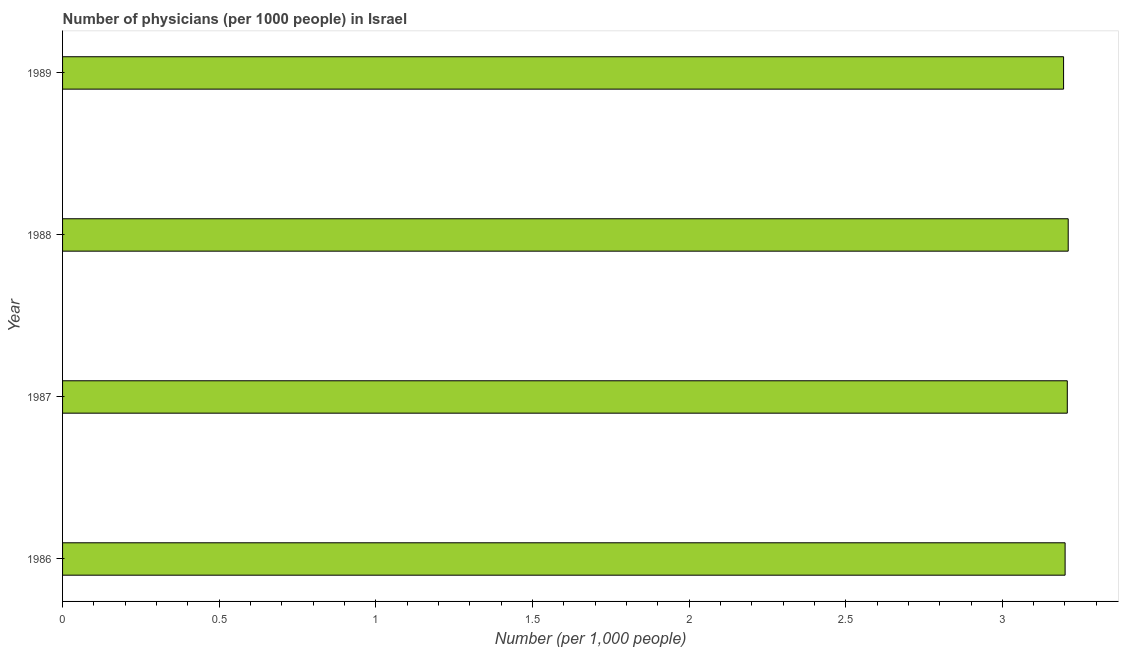Does the graph contain any zero values?
Provide a short and direct response. No. Does the graph contain grids?
Offer a terse response. No. What is the title of the graph?
Give a very brief answer. Number of physicians (per 1000 people) in Israel. What is the label or title of the X-axis?
Provide a succinct answer. Number (per 1,0 people). What is the label or title of the Y-axis?
Provide a succinct answer. Year. What is the number of physicians in 1986?
Offer a very short reply. 3.2. Across all years, what is the maximum number of physicians?
Your answer should be compact. 3.21. Across all years, what is the minimum number of physicians?
Offer a terse response. 3.2. In which year was the number of physicians maximum?
Provide a succinct answer. 1988. What is the sum of the number of physicians?
Keep it short and to the point. 12.81. What is the difference between the number of physicians in 1987 and 1989?
Your answer should be very brief. 0.01. What is the average number of physicians per year?
Provide a short and direct response. 3.2. What is the median number of physicians?
Ensure brevity in your answer.  3.2. In how many years, is the number of physicians greater than 2.2 ?
Give a very brief answer. 4. Do a majority of the years between 1988 and 1989 (inclusive) have number of physicians greater than 3 ?
Your response must be concise. Yes. What is the ratio of the number of physicians in 1986 to that in 1988?
Your answer should be very brief. 1. Is the number of physicians in 1986 less than that in 1989?
Give a very brief answer. No. Is the difference between the number of physicians in 1987 and 1988 greater than the difference between any two years?
Ensure brevity in your answer.  No. What is the difference between the highest and the second highest number of physicians?
Offer a terse response. 0. Is the sum of the number of physicians in 1988 and 1989 greater than the maximum number of physicians across all years?
Offer a terse response. Yes. In how many years, is the number of physicians greater than the average number of physicians taken over all years?
Your response must be concise. 2. How many years are there in the graph?
Keep it short and to the point. 4. Are the values on the major ticks of X-axis written in scientific E-notation?
Offer a very short reply. No. What is the Number (per 1,000 people) of 1986?
Your answer should be compact. 3.2. What is the Number (per 1,000 people) of 1987?
Offer a terse response. 3.21. What is the Number (per 1,000 people) in 1988?
Your answer should be compact. 3.21. What is the Number (per 1,000 people) in 1989?
Offer a terse response. 3.2. What is the difference between the Number (per 1,000 people) in 1986 and 1987?
Ensure brevity in your answer.  -0.01. What is the difference between the Number (per 1,000 people) in 1986 and 1988?
Give a very brief answer. -0.01. What is the difference between the Number (per 1,000 people) in 1986 and 1989?
Give a very brief answer. 0. What is the difference between the Number (per 1,000 people) in 1987 and 1988?
Give a very brief answer. -0. What is the difference between the Number (per 1,000 people) in 1987 and 1989?
Ensure brevity in your answer.  0.01. What is the difference between the Number (per 1,000 people) in 1988 and 1989?
Provide a short and direct response. 0.01. What is the ratio of the Number (per 1,000 people) in 1986 to that in 1988?
Offer a terse response. 1. What is the ratio of the Number (per 1,000 people) in 1987 to that in 1988?
Your answer should be very brief. 1. 